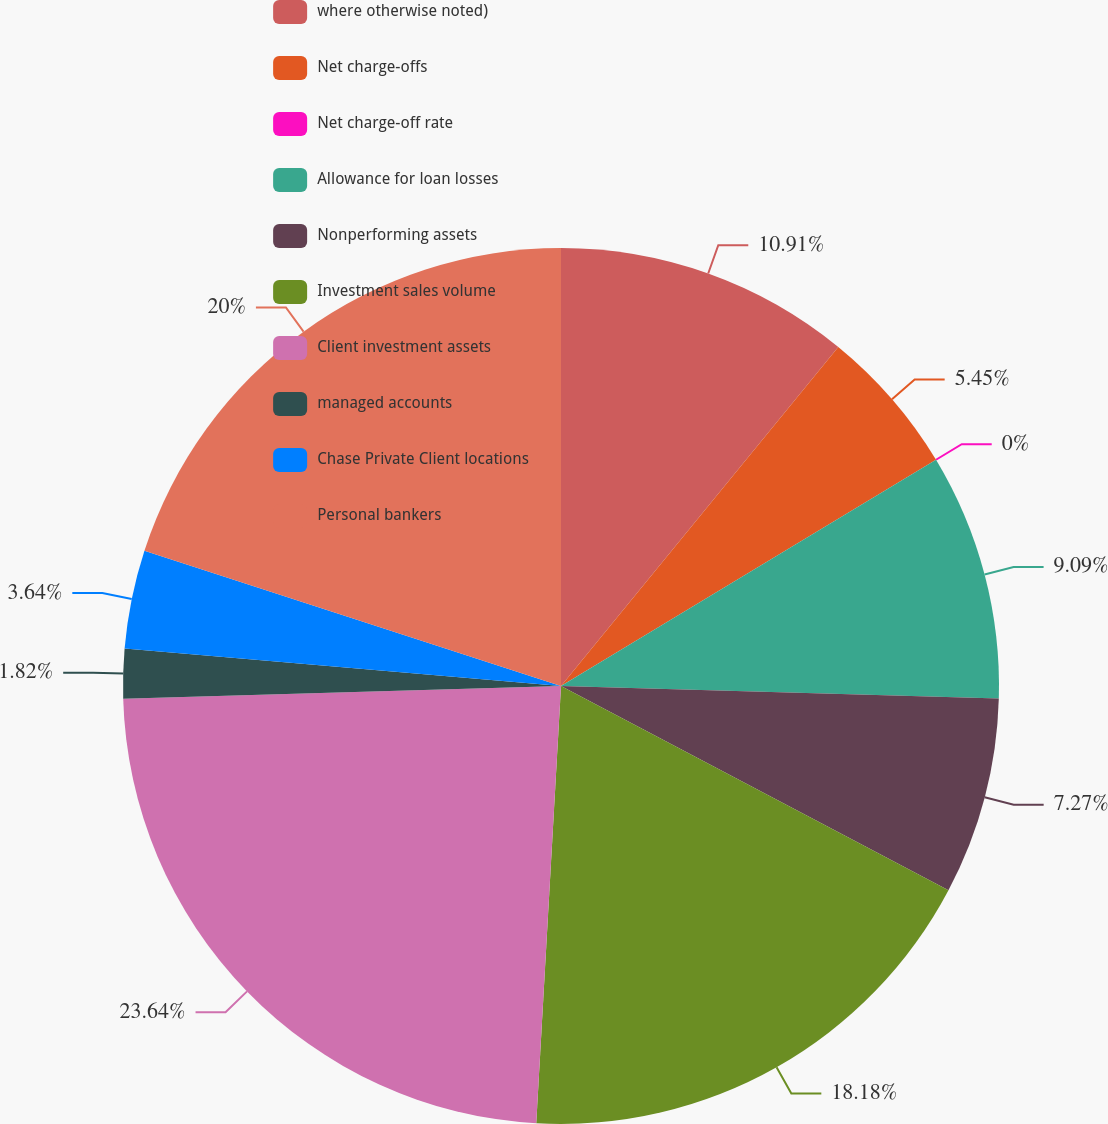<chart> <loc_0><loc_0><loc_500><loc_500><pie_chart><fcel>where otherwise noted)<fcel>Net charge-offs<fcel>Net charge-off rate<fcel>Allowance for loan losses<fcel>Nonperforming assets<fcel>Investment sales volume<fcel>Client investment assets<fcel>managed accounts<fcel>Chase Private Client locations<fcel>Personal bankers<nl><fcel>10.91%<fcel>5.45%<fcel>0.0%<fcel>9.09%<fcel>7.27%<fcel>18.18%<fcel>23.64%<fcel>1.82%<fcel>3.64%<fcel>20.0%<nl></chart> 